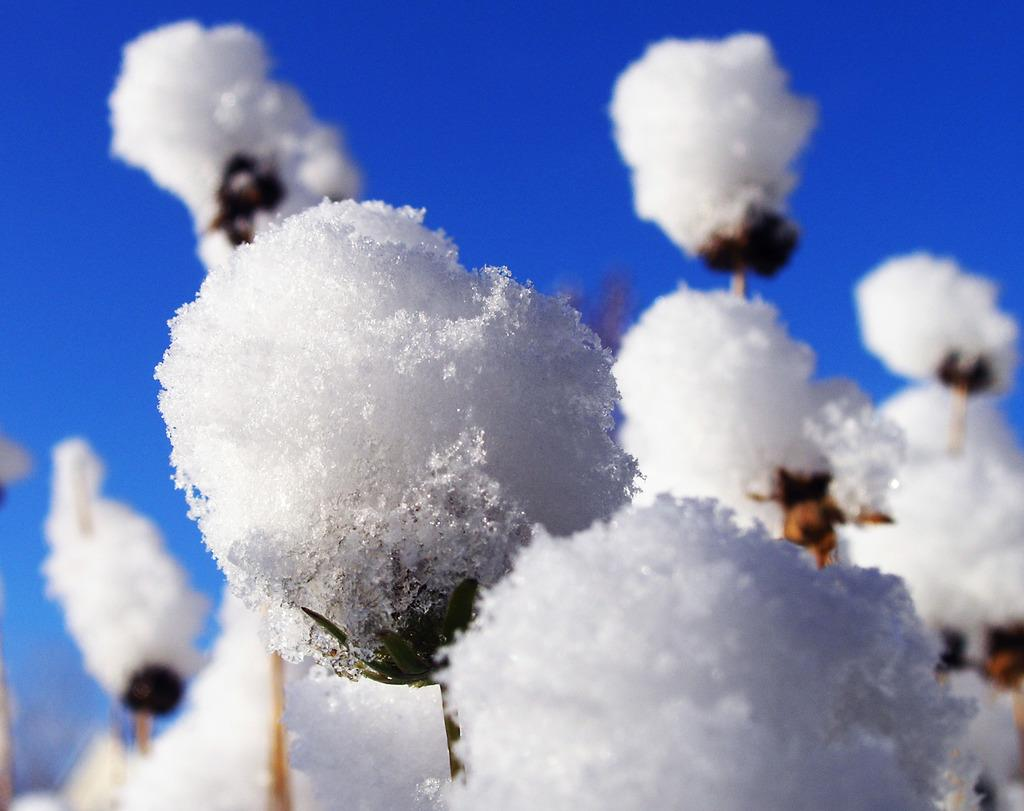What celestial bodies are present in the image? There are planets in the image. What specific feature can be observed on the planets? The planets have snow on them. What part of the natural environment is visible in the image? The sky is visible in the background of the image. What type of show can be seen happening on the planets in the image? There is no show happening on the planets in the image; they are simply depicted with snow on them. How can the planets in the image be helped to reduce the snow on them? The image is a depiction and not a real-life scenario, so there is no way to help the planets in the image. 